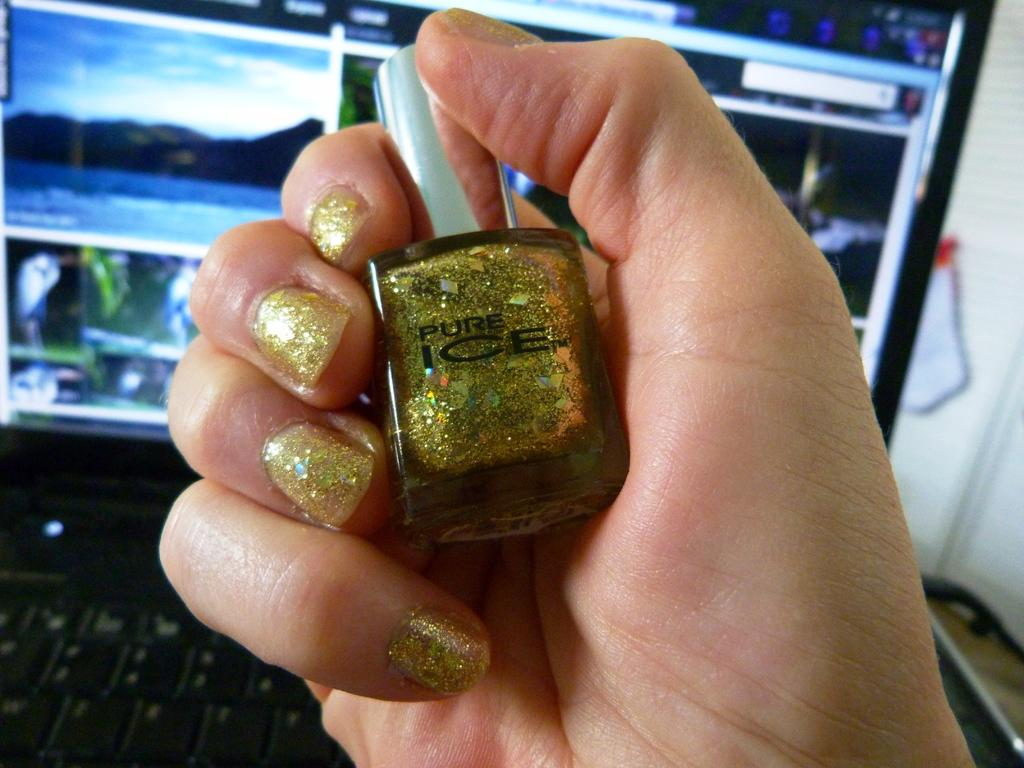Provide a one-sentence caption for the provided image. A hand is holding a bottle of gold nail polish labelled Pure Ice. 